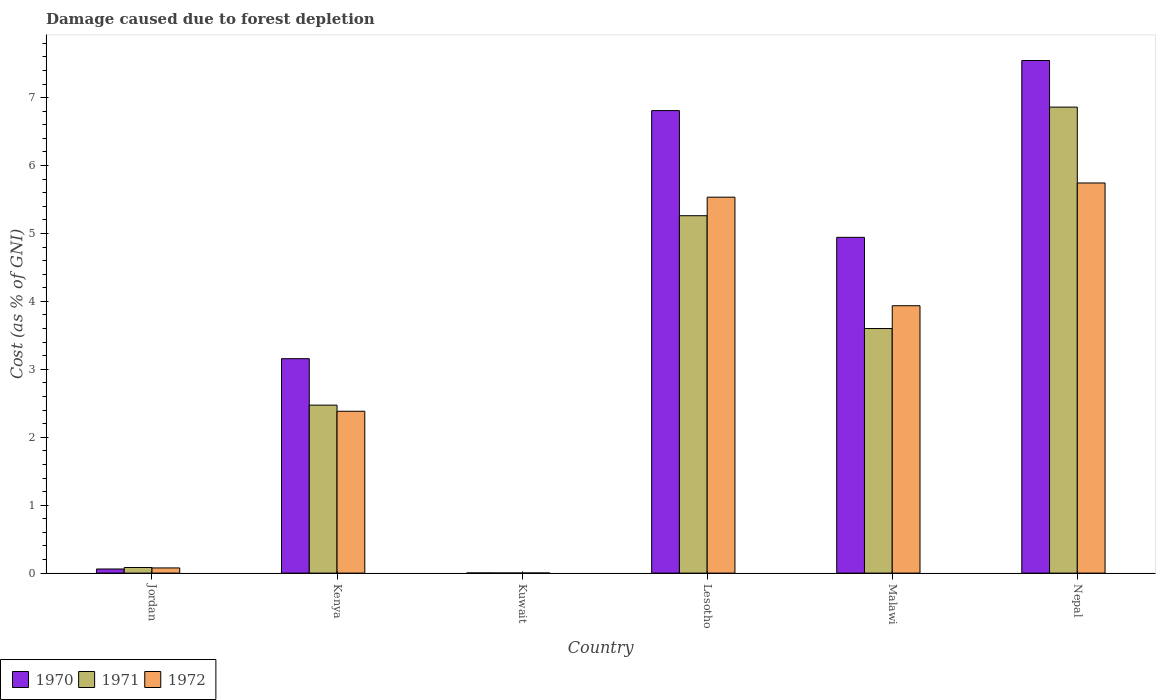How many different coloured bars are there?
Ensure brevity in your answer.  3. How many groups of bars are there?
Your answer should be compact. 6. Are the number of bars on each tick of the X-axis equal?
Your answer should be very brief. Yes. How many bars are there on the 1st tick from the left?
Your answer should be very brief. 3. What is the label of the 1st group of bars from the left?
Give a very brief answer. Jordan. What is the cost of damage caused due to forest depletion in 1972 in Lesotho?
Ensure brevity in your answer.  5.53. Across all countries, what is the maximum cost of damage caused due to forest depletion in 1972?
Offer a terse response. 5.74. Across all countries, what is the minimum cost of damage caused due to forest depletion in 1971?
Keep it short and to the point. 0. In which country was the cost of damage caused due to forest depletion in 1970 maximum?
Your response must be concise. Nepal. In which country was the cost of damage caused due to forest depletion in 1970 minimum?
Offer a very short reply. Kuwait. What is the total cost of damage caused due to forest depletion in 1972 in the graph?
Offer a very short reply. 17.67. What is the difference between the cost of damage caused due to forest depletion in 1972 in Kuwait and that in Lesotho?
Your response must be concise. -5.53. What is the difference between the cost of damage caused due to forest depletion in 1970 in Nepal and the cost of damage caused due to forest depletion in 1971 in Kenya?
Offer a terse response. 5.07. What is the average cost of damage caused due to forest depletion in 1972 per country?
Keep it short and to the point. 2.95. What is the difference between the cost of damage caused due to forest depletion of/in 1972 and cost of damage caused due to forest depletion of/in 1970 in Kenya?
Provide a succinct answer. -0.77. What is the ratio of the cost of damage caused due to forest depletion in 1971 in Jordan to that in Kenya?
Provide a succinct answer. 0.03. What is the difference between the highest and the second highest cost of damage caused due to forest depletion in 1972?
Give a very brief answer. 1.6. What is the difference between the highest and the lowest cost of damage caused due to forest depletion in 1972?
Provide a short and direct response. 5.74. Is the sum of the cost of damage caused due to forest depletion in 1971 in Lesotho and Malawi greater than the maximum cost of damage caused due to forest depletion in 1972 across all countries?
Provide a short and direct response. Yes. Is it the case that in every country, the sum of the cost of damage caused due to forest depletion in 1970 and cost of damage caused due to forest depletion in 1972 is greater than the cost of damage caused due to forest depletion in 1971?
Keep it short and to the point. Yes. What is the difference between two consecutive major ticks on the Y-axis?
Provide a succinct answer. 1. Does the graph contain any zero values?
Your response must be concise. No. Does the graph contain grids?
Your answer should be very brief. No. Where does the legend appear in the graph?
Offer a terse response. Bottom left. How many legend labels are there?
Make the answer very short. 3. How are the legend labels stacked?
Offer a very short reply. Horizontal. What is the title of the graph?
Give a very brief answer. Damage caused due to forest depletion. What is the label or title of the X-axis?
Keep it short and to the point. Country. What is the label or title of the Y-axis?
Offer a very short reply. Cost (as % of GNI). What is the Cost (as % of GNI) in 1970 in Jordan?
Your answer should be very brief. 0.06. What is the Cost (as % of GNI) in 1971 in Jordan?
Provide a short and direct response. 0.08. What is the Cost (as % of GNI) of 1972 in Jordan?
Your answer should be compact. 0.08. What is the Cost (as % of GNI) of 1970 in Kenya?
Offer a very short reply. 3.16. What is the Cost (as % of GNI) in 1971 in Kenya?
Provide a succinct answer. 2.47. What is the Cost (as % of GNI) in 1972 in Kenya?
Your answer should be very brief. 2.38. What is the Cost (as % of GNI) of 1970 in Kuwait?
Offer a terse response. 0. What is the Cost (as % of GNI) of 1971 in Kuwait?
Your answer should be very brief. 0. What is the Cost (as % of GNI) in 1972 in Kuwait?
Keep it short and to the point. 0. What is the Cost (as % of GNI) in 1970 in Lesotho?
Offer a terse response. 6.81. What is the Cost (as % of GNI) in 1971 in Lesotho?
Provide a succinct answer. 5.26. What is the Cost (as % of GNI) of 1972 in Lesotho?
Offer a very short reply. 5.53. What is the Cost (as % of GNI) in 1970 in Malawi?
Ensure brevity in your answer.  4.94. What is the Cost (as % of GNI) in 1971 in Malawi?
Offer a terse response. 3.6. What is the Cost (as % of GNI) in 1972 in Malawi?
Make the answer very short. 3.94. What is the Cost (as % of GNI) in 1970 in Nepal?
Give a very brief answer. 7.55. What is the Cost (as % of GNI) of 1971 in Nepal?
Provide a short and direct response. 6.86. What is the Cost (as % of GNI) of 1972 in Nepal?
Ensure brevity in your answer.  5.74. Across all countries, what is the maximum Cost (as % of GNI) of 1970?
Your answer should be compact. 7.55. Across all countries, what is the maximum Cost (as % of GNI) of 1971?
Your answer should be very brief. 6.86. Across all countries, what is the maximum Cost (as % of GNI) in 1972?
Make the answer very short. 5.74. Across all countries, what is the minimum Cost (as % of GNI) of 1970?
Offer a very short reply. 0. Across all countries, what is the minimum Cost (as % of GNI) of 1971?
Offer a very short reply. 0. Across all countries, what is the minimum Cost (as % of GNI) in 1972?
Your answer should be very brief. 0. What is the total Cost (as % of GNI) of 1970 in the graph?
Keep it short and to the point. 22.52. What is the total Cost (as % of GNI) in 1971 in the graph?
Your answer should be compact. 18.28. What is the total Cost (as % of GNI) of 1972 in the graph?
Offer a terse response. 17.67. What is the difference between the Cost (as % of GNI) in 1970 in Jordan and that in Kenya?
Keep it short and to the point. -3.1. What is the difference between the Cost (as % of GNI) of 1971 in Jordan and that in Kenya?
Your answer should be very brief. -2.39. What is the difference between the Cost (as % of GNI) in 1972 in Jordan and that in Kenya?
Offer a terse response. -2.31. What is the difference between the Cost (as % of GNI) of 1970 in Jordan and that in Kuwait?
Offer a terse response. 0.06. What is the difference between the Cost (as % of GNI) of 1971 in Jordan and that in Kuwait?
Your answer should be very brief. 0.08. What is the difference between the Cost (as % of GNI) of 1972 in Jordan and that in Kuwait?
Give a very brief answer. 0.07. What is the difference between the Cost (as % of GNI) of 1970 in Jordan and that in Lesotho?
Keep it short and to the point. -6.75. What is the difference between the Cost (as % of GNI) of 1971 in Jordan and that in Lesotho?
Make the answer very short. -5.18. What is the difference between the Cost (as % of GNI) of 1972 in Jordan and that in Lesotho?
Your answer should be compact. -5.46. What is the difference between the Cost (as % of GNI) of 1970 in Jordan and that in Malawi?
Give a very brief answer. -4.88. What is the difference between the Cost (as % of GNI) in 1971 in Jordan and that in Malawi?
Offer a very short reply. -3.52. What is the difference between the Cost (as % of GNI) of 1972 in Jordan and that in Malawi?
Your answer should be very brief. -3.86. What is the difference between the Cost (as % of GNI) of 1970 in Jordan and that in Nepal?
Keep it short and to the point. -7.49. What is the difference between the Cost (as % of GNI) of 1971 in Jordan and that in Nepal?
Keep it short and to the point. -6.78. What is the difference between the Cost (as % of GNI) in 1972 in Jordan and that in Nepal?
Keep it short and to the point. -5.67. What is the difference between the Cost (as % of GNI) of 1970 in Kenya and that in Kuwait?
Your answer should be very brief. 3.15. What is the difference between the Cost (as % of GNI) of 1971 in Kenya and that in Kuwait?
Your answer should be compact. 2.47. What is the difference between the Cost (as % of GNI) of 1972 in Kenya and that in Kuwait?
Provide a succinct answer. 2.38. What is the difference between the Cost (as % of GNI) of 1970 in Kenya and that in Lesotho?
Offer a terse response. -3.65. What is the difference between the Cost (as % of GNI) in 1971 in Kenya and that in Lesotho?
Ensure brevity in your answer.  -2.79. What is the difference between the Cost (as % of GNI) in 1972 in Kenya and that in Lesotho?
Keep it short and to the point. -3.15. What is the difference between the Cost (as % of GNI) in 1970 in Kenya and that in Malawi?
Make the answer very short. -1.79. What is the difference between the Cost (as % of GNI) of 1971 in Kenya and that in Malawi?
Provide a succinct answer. -1.13. What is the difference between the Cost (as % of GNI) in 1972 in Kenya and that in Malawi?
Offer a very short reply. -1.55. What is the difference between the Cost (as % of GNI) in 1970 in Kenya and that in Nepal?
Keep it short and to the point. -4.39. What is the difference between the Cost (as % of GNI) in 1971 in Kenya and that in Nepal?
Your response must be concise. -4.39. What is the difference between the Cost (as % of GNI) in 1972 in Kenya and that in Nepal?
Your answer should be very brief. -3.36. What is the difference between the Cost (as % of GNI) in 1970 in Kuwait and that in Lesotho?
Your answer should be compact. -6.81. What is the difference between the Cost (as % of GNI) in 1971 in Kuwait and that in Lesotho?
Provide a short and direct response. -5.26. What is the difference between the Cost (as % of GNI) of 1972 in Kuwait and that in Lesotho?
Offer a very short reply. -5.53. What is the difference between the Cost (as % of GNI) in 1970 in Kuwait and that in Malawi?
Keep it short and to the point. -4.94. What is the difference between the Cost (as % of GNI) of 1971 in Kuwait and that in Malawi?
Your answer should be very brief. -3.6. What is the difference between the Cost (as % of GNI) of 1972 in Kuwait and that in Malawi?
Provide a short and direct response. -3.94. What is the difference between the Cost (as % of GNI) of 1970 in Kuwait and that in Nepal?
Keep it short and to the point. -7.54. What is the difference between the Cost (as % of GNI) in 1971 in Kuwait and that in Nepal?
Your response must be concise. -6.86. What is the difference between the Cost (as % of GNI) in 1972 in Kuwait and that in Nepal?
Ensure brevity in your answer.  -5.74. What is the difference between the Cost (as % of GNI) in 1970 in Lesotho and that in Malawi?
Offer a very short reply. 1.87. What is the difference between the Cost (as % of GNI) in 1971 in Lesotho and that in Malawi?
Your answer should be very brief. 1.66. What is the difference between the Cost (as % of GNI) in 1972 in Lesotho and that in Malawi?
Provide a succinct answer. 1.6. What is the difference between the Cost (as % of GNI) in 1970 in Lesotho and that in Nepal?
Give a very brief answer. -0.74. What is the difference between the Cost (as % of GNI) in 1971 in Lesotho and that in Nepal?
Your answer should be very brief. -1.6. What is the difference between the Cost (as % of GNI) in 1972 in Lesotho and that in Nepal?
Offer a very short reply. -0.21. What is the difference between the Cost (as % of GNI) of 1970 in Malawi and that in Nepal?
Your answer should be compact. -2.6. What is the difference between the Cost (as % of GNI) in 1971 in Malawi and that in Nepal?
Offer a terse response. -3.26. What is the difference between the Cost (as % of GNI) in 1972 in Malawi and that in Nepal?
Offer a very short reply. -1.81. What is the difference between the Cost (as % of GNI) in 1970 in Jordan and the Cost (as % of GNI) in 1971 in Kenya?
Provide a succinct answer. -2.41. What is the difference between the Cost (as % of GNI) of 1970 in Jordan and the Cost (as % of GNI) of 1972 in Kenya?
Your answer should be very brief. -2.32. What is the difference between the Cost (as % of GNI) of 1971 in Jordan and the Cost (as % of GNI) of 1972 in Kenya?
Your answer should be very brief. -2.3. What is the difference between the Cost (as % of GNI) of 1970 in Jordan and the Cost (as % of GNI) of 1971 in Kuwait?
Give a very brief answer. 0.06. What is the difference between the Cost (as % of GNI) in 1970 in Jordan and the Cost (as % of GNI) in 1972 in Kuwait?
Provide a short and direct response. 0.06. What is the difference between the Cost (as % of GNI) in 1971 in Jordan and the Cost (as % of GNI) in 1972 in Kuwait?
Your answer should be very brief. 0.08. What is the difference between the Cost (as % of GNI) of 1970 in Jordan and the Cost (as % of GNI) of 1971 in Lesotho?
Your response must be concise. -5.2. What is the difference between the Cost (as % of GNI) in 1970 in Jordan and the Cost (as % of GNI) in 1972 in Lesotho?
Offer a terse response. -5.47. What is the difference between the Cost (as % of GNI) of 1971 in Jordan and the Cost (as % of GNI) of 1972 in Lesotho?
Your answer should be compact. -5.45. What is the difference between the Cost (as % of GNI) of 1970 in Jordan and the Cost (as % of GNI) of 1971 in Malawi?
Keep it short and to the point. -3.54. What is the difference between the Cost (as % of GNI) of 1970 in Jordan and the Cost (as % of GNI) of 1972 in Malawi?
Offer a very short reply. -3.88. What is the difference between the Cost (as % of GNI) of 1971 in Jordan and the Cost (as % of GNI) of 1972 in Malawi?
Offer a terse response. -3.85. What is the difference between the Cost (as % of GNI) of 1970 in Jordan and the Cost (as % of GNI) of 1971 in Nepal?
Offer a terse response. -6.8. What is the difference between the Cost (as % of GNI) in 1970 in Jordan and the Cost (as % of GNI) in 1972 in Nepal?
Keep it short and to the point. -5.68. What is the difference between the Cost (as % of GNI) of 1971 in Jordan and the Cost (as % of GNI) of 1972 in Nepal?
Offer a very short reply. -5.66. What is the difference between the Cost (as % of GNI) in 1970 in Kenya and the Cost (as % of GNI) in 1971 in Kuwait?
Provide a succinct answer. 3.16. What is the difference between the Cost (as % of GNI) of 1970 in Kenya and the Cost (as % of GNI) of 1972 in Kuwait?
Provide a succinct answer. 3.16. What is the difference between the Cost (as % of GNI) of 1971 in Kenya and the Cost (as % of GNI) of 1972 in Kuwait?
Offer a very short reply. 2.47. What is the difference between the Cost (as % of GNI) of 1970 in Kenya and the Cost (as % of GNI) of 1971 in Lesotho?
Offer a terse response. -2.1. What is the difference between the Cost (as % of GNI) in 1970 in Kenya and the Cost (as % of GNI) in 1972 in Lesotho?
Your response must be concise. -2.38. What is the difference between the Cost (as % of GNI) of 1971 in Kenya and the Cost (as % of GNI) of 1972 in Lesotho?
Your response must be concise. -3.06. What is the difference between the Cost (as % of GNI) of 1970 in Kenya and the Cost (as % of GNI) of 1971 in Malawi?
Provide a succinct answer. -0.44. What is the difference between the Cost (as % of GNI) in 1970 in Kenya and the Cost (as % of GNI) in 1972 in Malawi?
Your answer should be very brief. -0.78. What is the difference between the Cost (as % of GNI) of 1971 in Kenya and the Cost (as % of GNI) of 1972 in Malawi?
Your answer should be very brief. -1.46. What is the difference between the Cost (as % of GNI) of 1970 in Kenya and the Cost (as % of GNI) of 1971 in Nepal?
Your response must be concise. -3.7. What is the difference between the Cost (as % of GNI) of 1970 in Kenya and the Cost (as % of GNI) of 1972 in Nepal?
Offer a terse response. -2.59. What is the difference between the Cost (as % of GNI) in 1971 in Kenya and the Cost (as % of GNI) in 1972 in Nepal?
Give a very brief answer. -3.27. What is the difference between the Cost (as % of GNI) of 1970 in Kuwait and the Cost (as % of GNI) of 1971 in Lesotho?
Keep it short and to the point. -5.26. What is the difference between the Cost (as % of GNI) of 1970 in Kuwait and the Cost (as % of GNI) of 1972 in Lesotho?
Make the answer very short. -5.53. What is the difference between the Cost (as % of GNI) of 1971 in Kuwait and the Cost (as % of GNI) of 1972 in Lesotho?
Your answer should be very brief. -5.53. What is the difference between the Cost (as % of GNI) in 1970 in Kuwait and the Cost (as % of GNI) in 1971 in Malawi?
Give a very brief answer. -3.6. What is the difference between the Cost (as % of GNI) in 1970 in Kuwait and the Cost (as % of GNI) in 1972 in Malawi?
Your answer should be very brief. -3.93. What is the difference between the Cost (as % of GNI) in 1971 in Kuwait and the Cost (as % of GNI) in 1972 in Malawi?
Your response must be concise. -3.94. What is the difference between the Cost (as % of GNI) of 1970 in Kuwait and the Cost (as % of GNI) of 1971 in Nepal?
Your answer should be compact. -6.86. What is the difference between the Cost (as % of GNI) in 1970 in Kuwait and the Cost (as % of GNI) in 1972 in Nepal?
Ensure brevity in your answer.  -5.74. What is the difference between the Cost (as % of GNI) in 1971 in Kuwait and the Cost (as % of GNI) in 1972 in Nepal?
Provide a short and direct response. -5.74. What is the difference between the Cost (as % of GNI) of 1970 in Lesotho and the Cost (as % of GNI) of 1971 in Malawi?
Give a very brief answer. 3.21. What is the difference between the Cost (as % of GNI) in 1970 in Lesotho and the Cost (as % of GNI) in 1972 in Malawi?
Give a very brief answer. 2.87. What is the difference between the Cost (as % of GNI) of 1971 in Lesotho and the Cost (as % of GNI) of 1972 in Malawi?
Ensure brevity in your answer.  1.33. What is the difference between the Cost (as % of GNI) of 1970 in Lesotho and the Cost (as % of GNI) of 1971 in Nepal?
Keep it short and to the point. -0.05. What is the difference between the Cost (as % of GNI) in 1970 in Lesotho and the Cost (as % of GNI) in 1972 in Nepal?
Your answer should be very brief. 1.07. What is the difference between the Cost (as % of GNI) in 1971 in Lesotho and the Cost (as % of GNI) in 1972 in Nepal?
Your response must be concise. -0.48. What is the difference between the Cost (as % of GNI) in 1970 in Malawi and the Cost (as % of GNI) in 1971 in Nepal?
Offer a very short reply. -1.92. What is the difference between the Cost (as % of GNI) of 1970 in Malawi and the Cost (as % of GNI) of 1972 in Nepal?
Give a very brief answer. -0.8. What is the difference between the Cost (as % of GNI) in 1971 in Malawi and the Cost (as % of GNI) in 1972 in Nepal?
Provide a succinct answer. -2.14. What is the average Cost (as % of GNI) of 1970 per country?
Give a very brief answer. 3.75. What is the average Cost (as % of GNI) of 1971 per country?
Ensure brevity in your answer.  3.05. What is the average Cost (as % of GNI) in 1972 per country?
Your response must be concise. 2.95. What is the difference between the Cost (as % of GNI) of 1970 and Cost (as % of GNI) of 1971 in Jordan?
Make the answer very short. -0.02. What is the difference between the Cost (as % of GNI) in 1970 and Cost (as % of GNI) in 1972 in Jordan?
Offer a terse response. -0.02. What is the difference between the Cost (as % of GNI) of 1971 and Cost (as % of GNI) of 1972 in Jordan?
Your answer should be compact. 0.01. What is the difference between the Cost (as % of GNI) of 1970 and Cost (as % of GNI) of 1971 in Kenya?
Make the answer very short. 0.68. What is the difference between the Cost (as % of GNI) of 1970 and Cost (as % of GNI) of 1972 in Kenya?
Your answer should be very brief. 0.77. What is the difference between the Cost (as % of GNI) of 1971 and Cost (as % of GNI) of 1972 in Kenya?
Provide a short and direct response. 0.09. What is the difference between the Cost (as % of GNI) in 1970 and Cost (as % of GNI) in 1971 in Kuwait?
Provide a short and direct response. 0. What is the difference between the Cost (as % of GNI) of 1970 and Cost (as % of GNI) of 1972 in Kuwait?
Offer a terse response. 0. What is the difference between the Cost (as % of GNI) of 1971 and Cost (as % of GNI) of 1972 in Kuwait?
Provide a short and direct response. -0. What is the difference between the Cost (as % of GNI) in 1970 and Cost (as % of GNI) in 1971 in Lesotho?
Offer a very short reply. 1.55. What is the difference between the Cost (as % of GNI) of 1970 and Cost (as % of GNI) of 1972 in Lesotho?
Offer a terse response. 1.27. What is the difference between the Cost (as % of GNI) of 1971 and Cost (as % of GNI) of 1972 in Lesotho?
Make the answer very short. -0.27. What is the difference between the Cost (as % of GNI) of 1970 and Cost (as % of GNI) of 1971 in Malawi?
Your answer should be very brief. 1.34. What is the difference between the Cost (as % of GNI) in 1970 and Cost (as % of GNI) in 1972 in Malawi?
Offer a very short reply. 1.01. What is the difference between the Cost (as % of GNI) in 1971 and Cost (as % of GNI) in 1972 in Malawi?
Your answer should be very brief. -0.34. What is the difference between the Cost (as % of GNI) in 1970 and Cost (as % of GNI) in 1971 in Nepal?
Keep it short and to the point. 0.69. What is the difference between the Cost (as % of GNI) in 1970 and Cost (as % of GNI) in 1972 in Nepal?
Ensure brevity in your answer.  1.8. What is the difference between the Cost (as % of GNI) of 1971 and Cost (as % of GNI) of 1972 in Nepal?
Offer a terse response. 1.12. What is the ratio of the Cost (as % of GNI) in 1970 in Jordan to that in Kenya?
Give a very brief answer. 0.02. What is the ratio of the Cost (as % of GNI) of 1972 in Jordan to that in Kenya?
Provide a short and direct response. 0.03. What is the ratio of the Cost (as % of GNI) of 1970 in Jordan to that in Kuwait?
Your answer should be very brief. 29.43. What is the ratio of the Cost (as % of GNI) in 1971 in Jordan to that in Kuwait?
Ensure brevity in your answer.  68.45. What is the ratio of the Cost (as % of GNI) of 1972 in Jordan to that in Kuwait?
Offer a terse response. 57.8. What is the ratio of the Cost (as % of GNI) of 1970 in Jordan to that in Lesotho?
Your answer should be very brief. 0.01. What is the ratio of the Cost (as % of GNI) of 1971 in Jordan to that in Lesotho?
Provide a short and direct response. 0.02. What is the ratio of the Cost (as % of GNI) in 1972 in Jordan to that in Lesotho?
Offer a terse response. 0.01. What is the ratio of the Cost (as % of GNI) in 1970 in Jordan to that in Malawi?
Give a very brief answer. 0.01. What is the ratio of the Cost (as % of GNI) of 1971 in Jordan to that in Malawi?
Ensure brevity in your answer.  0.02. What is the ratio of the Cost (as % of GNI) in 1972 in Jordan to that in Malawi?
Keep it short and to the point. 0.02. What is the ratio of the Cost (as % of GNI) in 1970 in Jordan to that in Nepal?
Give a very brief answer. 0.01. What is the ratio of the Cost (as % of GNI) in 1971 in Jordan to that in Nepal?
Your response must be concise. 0.01. What is the ratio of the Cost (as % of GNI) of 1972 in Jordan to that in Nepal?
Offer a terse response. 0.01. What is the ratio of the Cost (as % of GNI) of 1970 in Kenya to that in Kuwait?
Provide a succinct answer. 1538.88. What is the ratio of the Cost (as % of GNI) in 1971 in Kenya to that in Kuwait?
Provide a succinct answer. 2052.57. What is the ratio of the Cost (as % of GNI) in 1972 in Kenya to that in Kuwait?
Provide a short and direct response. 1809.3. What is the ratio of the Cost (as % of GNI) in 1970 in Kenya to that in Lesotho?
Ensure brevity in your answer.  0.46. What is the ratio of the Cost (as % of GNI) in 1971 in Kenya to that in Lesotho?
Your response must be concise. 0.47. What is the ratio of the Cost (as % of GNI) in 1972 in Kenya to that in Lesotho?
Provide a succinct answer. 0.43. What is the ratio of the Cost (as % of GNI) in 1970 in Kenya to that in Malawi?
Your response must be concise. 0.64. What is the ratio of the Cost (as % of GNI) of 1971 in Kenya to that in Malawi?
Your answer should be compact. 0.69. What is the ratio of the Cost (as % of GNI) of 1972 in Kenya to that in Malawi?
Make the answer very short. 0.61. What is the ratio of the Cost (as % of GNI) of 1970 in Kenya to that in Nepal?
Offer a terse response. 0.42. What is the ratio of the Cost (as % of GNI) of 1971 in Kenya to that in Nepal?
Make the answer very short. 0.36. What is the ratio of the Cost (as % of GNI) in 1972 in Kenya to that in Nepal?
Provide a short and direct response. 0.41. What is the ratio of the Cost (as % of GNI) of 1970 in Kuwait to that in Lesotho?
Keep it short and to the point. 0. What is the ratio of the Cost (as % of GNI) of 1972 in Kuwait to that in Lesotho?
Ensure brevity in your answer.  0. What is the ratio of the Cost (as % of GNI) in 1970 in Kuwait to that in Malawi?
Keep it short and to the point. 0. What is the ratio of the Cost (as % of GNI) in 1972 in Kuwait to that in Malawi?
Provide a short and direct response. 0. What is the ratio of the Cost (as % of GNI) in 1971 in Kuwait to that in Nepal?
Keep it short and to the point. 0. What is the ratio of the Cost (as % of GNI) in 1972 in Kuwait to that in Nepal?
Give a very brief answer. 0. What is the ratio of the Cost (as % of GNI) of 1970 in Lesotho to that in Malawi?
Give a very brief answer. 1.38. What is the ratio of the Cost (as % of GNI) of 1971 in Lesotho to that in Malawi?
Your answer should be very brief. 1.46. What is the ratio of the Cost (as % of GNI) in 1972 in Lesotho to that in Malawi?
Offer a very short reply. 1.41. What is the ratio of the Cost (as % of GNI) in 1970 in Lesotho to that in Nepal?
Your answer should be compact. 0.9. What is the ratio of the Cost (as % of GNI) of 1971 in Lesotho to that in Nepal?
Your answer should be compact. 0.77. What is the ratio of the Cost (as % of GNI) in 1972 in Lesotho to that in Nepal?
Provide a succinct answer. 0.96. What is the ratio of the Cost (as % of GNI) of 1970 in Malawi to that in Nepal?
Provide a short and direct response. 0.66. What is the ratio of the Cost (as % of GNI) in 1971 in Malawi to that in Nepal?
Make the answer very short. 0.52. What is the ratio of the Cost (as % of GNI) of 1972 in Malawi to that in Nepal?
Offer a terse response. 0.69. What is the difference between the highest and the second highest Cost (as % of GNI) in 1970?
Give a very brief answer. 0.74. What is the difference between the highest and the second highest Cost (as % of GNI) of 1971?
Ensure brevity in your answer.  1.6. What is the difference between the highest and the second highest Cost (as % of GNI) of 1972?
Provide a short and direct response. 0.21. What is the difference between the highest and the lowest Cost (as % of GNI) in 1970?
Offer a very short reply. 7.54. What is the difference between the highest and the lowest Cost (as % of GNI) of 1971?
Keep it short and to the point. 6.86. What is the difference between the highest and the lowest Cost (as % of GNI) in 1972?
Give a very brief answer. 5.74. 